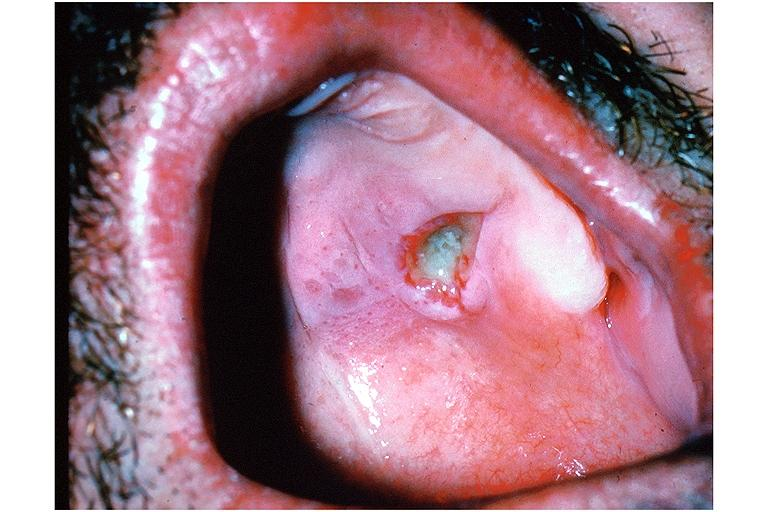does this image show necrotizing sialometaplasia?
Answer the question using a single word or phrase. Yes 